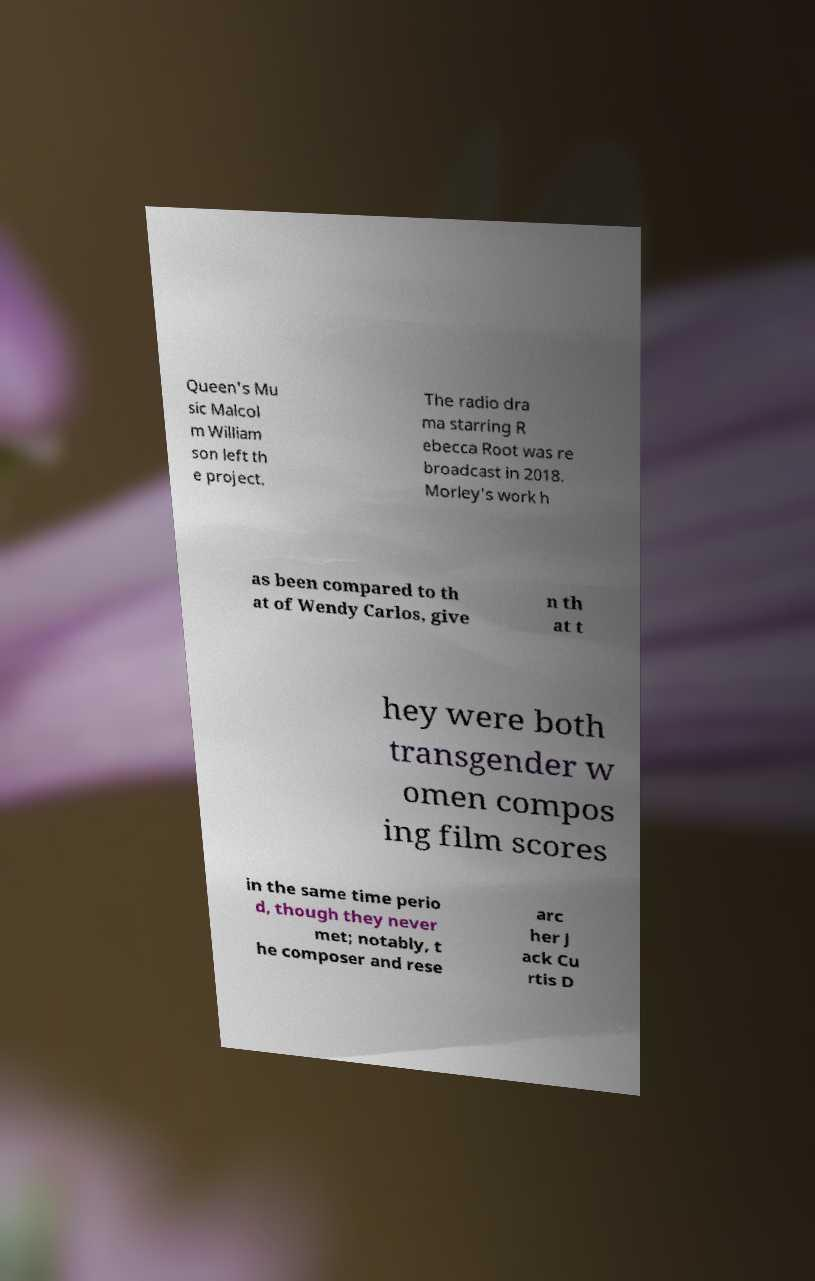There's text embedded in this image that I need extracted. Can you transcribe it verbatim? Queen's Mu sic Malcol m William son left th e project. The radio dra ma starring R ebecca Root was re broadcast in 2018. Morley's work h as been compared to th at of Wendy Carlos, give n th at t hey were both transgender w omen compos ing film scores in the same time perio d, though they never met; notably, t he composer and rese arc her J ack Cu rtis D 